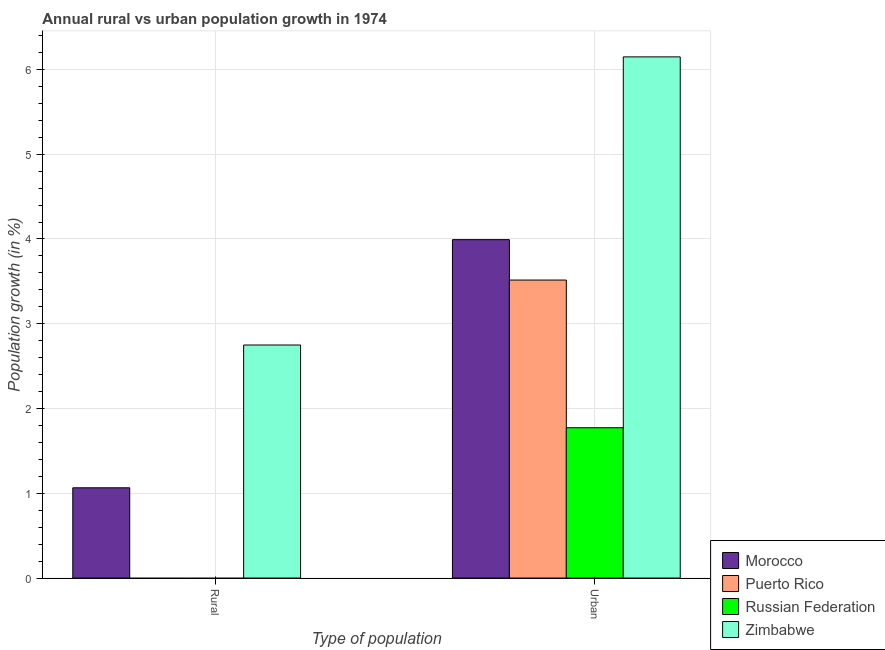How many groups of bars are there?
Provide a short and direct response. 2. How many bars are there on the 2nd tick from the right?
Your response must be concise. 2. What is the label of the 1st group of bars from the left?
Offer a very short reply. Rural. What is the rural population growth in Zimbabwe?
Your response must be concise. 2.75. Across all countries, what is the maximum rural population growth?
Ensure brevity in your answer.  2.75. Across all countries, what is the minimum urban population growth?
Make the answer very short. 1.77. In which country was the urban population growth maximum?
Offer a terse response. Zimbabwe. What is the total rural population growth in the graph?
Provide a succinct answer. 3.81. What is the difference between the urban population growth in Zimbabwe and that in Puerto Rico?
Keep it short and to the point. 2.63. What is the difference between the urban population growth in Puerto Rico and the rural population growth in Morocco?
Ensure brevity in your answer.  2.45. What is the average urban population growth per country?
Offer a terse response. 3.86. What is the difference between the rural population growth and urban population growth in Morocco?
Provide a short and direct response. -2.93. In how many countries, is the urban population growth greater than 4.4 %?
Keep it short and to the point. 1. What is the ratio of the urban population growth in Puerto Rico to that in Zimbabwe?
Ensure brevity in your answer.  0.57. Is the urban population growth in Puerto Rico less than that in Morocco?
Your answer should be very brief. Yes. In how many countries, is the urban population growth greater than the average urban population growth taken over all countries?
Your response must be concise. 2. Are all the bars in the graph horizontal?
Offer a terse response. No. How many countries are there in the graph?
Your response must be concise. 4. What is the difference between two consecutive major ticks on the Y-axis?
Offer a very short reply. 1. Are the values on the major ticks of Y-axis written in scientific E-notation?
Give a very brief answer. No. Where does the legend appear in the graph?
Provide a short and direct response. Bottom right. How are the legend labels stacked?
Keep it short and to the point. Vertical. What is the title of the graph?
Keep it short and to the point. Annual rural vs urban population growth in 1974. What is the label or title of the X-axis?
Offer a terse response. Type of population. What is the label or title of the Y-axis?
Provide a short and direct response. Population growth (in %). What is the Population growth (in %) in Morocco in Rural?
Your response must be concise. 1.06. What is the Population growth (in %) of Russian Federation in Rural?
Give a very brief answer. 0. What is the Population growth (in %) in Zimbabwe in Rural?
Keep it short and to the point. 2.75. What is the Population growth (in %) in Morocco in Urban ?
Provide a succinct answer. 3.99. What is the Population growth (in %) in Puerto Rico in Urban ?
Offer a very short reply. 3.52. What is the Population growth (in %) in Russian Federation in Urban ?
Provide a short and direct response. 1.77. What is the Population growth (in %) of Zimbabwe in Urban ?
Ensure brevity in your answer.  6.15. Across all Type of population, what is the maximum Population growth (in %) of Morocco?
Your answer should be compact. 3.99. Across all Type of population, what is the maximum Population growth (in %) in Puerto Rico?
Your response must be concise. 3.52. Across all Type of population, what is the maximum Population growth (in %) of Russian Federation?
Make the answer very short. 1.77. Across all Type of population, what is the maximum Population growth (in %) of Zimbabwe?
Your answer should be compact. 6.15. Across all Type of population, what is the minimum Population growth (in %) in Morocco?
Offer a terse response. 1.06. Across all Type of population, what is the minimum Population growth (in %) of Zimbabwe?
Provide a short and direct response. 2.75. What is the total Population growth (in %) in Morocco in the graph?
Offer a terse response. 5.06. What is the total Population growth (in %) of Puerto Rico in the graph?
Make the answer very short. 3.52. What is the total Population growth (in %) of Russian Federation in the graph?
Your answer should be compact. 1.77. What is the total Population growth (in %) in Zimbabwe in the graph?
Keep it short and to the point. 8.9. What is the difference between the Population growth (in %) in Morocco in Rural and that in Urban ?
Provide a short and direct response. -2.93. What is the difference between the Population growth (in %) of Zimbabwe in Rural and that in Urban ?
Provide a succinct answer. -3.4. What is the difference between the Population growth (in %) in Morocco in Rural and the Population growth (in %) in Puerto Rico in Urban?
Your response must be concise. -2.45. What is the difference between the Population growth (in %) in Morocco in Rural and the Population growth (in %) in Russian Federation in Urban?
Your response must be concise. -0.71. What is the difference between the Population growth (in %) in Morocco in Rural and the Population growth (in %) in Zimbabwe in Urban?
Provide a succinct answer. -5.08. What is the average Population growth (in %) in Morocco per Type of population?
Your answer should be very brief. 2.53. What is the average Population growth (in %) of Puerto Rico per Type of population?
Make the answer very short. 1.76. What is the average Population growth (in %) in Russian Federation per Type of population?
Your response must be concise. 0.89. What is the average Population growth (in %) of Zimbabwe per Type of population?
Offer a very short reply. 4.45. What is the difference between the Population growth (in %) in Morocco and Population growth (in %) in Zimbabwe in Rural?
Provide a short and direct response. -1.68. What is the difference between the Population growth (in %) in Morocco and Population growth (in %) in Puerto Rico in Urban ?
Ensure brevity in your answer.  0.48. What is the difference between the Population growth (in %) of Morocco and Population growth (in %) of Russian Federation in Urban ?
Provide a succinct answer. 2.22. What is the difference between the Population growth (in %) in Morocco and Population growth (in %) in Zimbabwe in Urban ?
Your answer should be compact. -2.16. What is the difference between the Population growth (in %) of Puerto Rico and Population growth (in %) of Russian Federation in Urban ?
Ensure brevity in your answer.  1.74. What is the difference between the Population growth (in %) of Puerto Rico and Population growth (in %) of Zimbabwe in Urban ?
Offer a very short reply. -2.63. What is the difference between the Population growth (in %) in Russian Federation and Population growth (in %) in Zimbabwe in Urban ?
Ensure brevity in your answer.  -4.38. What is the ratio of the Population growth (in %) in Morocco in Rural to that in Urban ?
Give a very brief answer. 0.27. What is the ratio of the Population growth (in %) of Zimbabwe in Rural to that in Urban ?
Provide a succinct answer. 0.45. What is the difference between the highest and the second highest Population growth (in %) in Morocco?
Give a very brief answer. 2.93. What is the difference between the highest and the second highest Population growth (in %) in Zimbabwe?
Keep it short and to the point. 3.4. What is the difference between the highest and the lowest Population growth (in %) in Morocco?
Provide a succinct answer. 2.93. What is the difference between the highest and the lowest Population growth (in %) of Puerto Rico?
Your answer should be compact. 3.52. What is the difference between the highest and the lowest Population growth (in %) in Russian Federation?
Ensure brevity in your answer.  1.77. What is the difference between the highest and the lowest Population growth (in %) of Zimbabwe?
Provide a succinct answer. 3.4. 